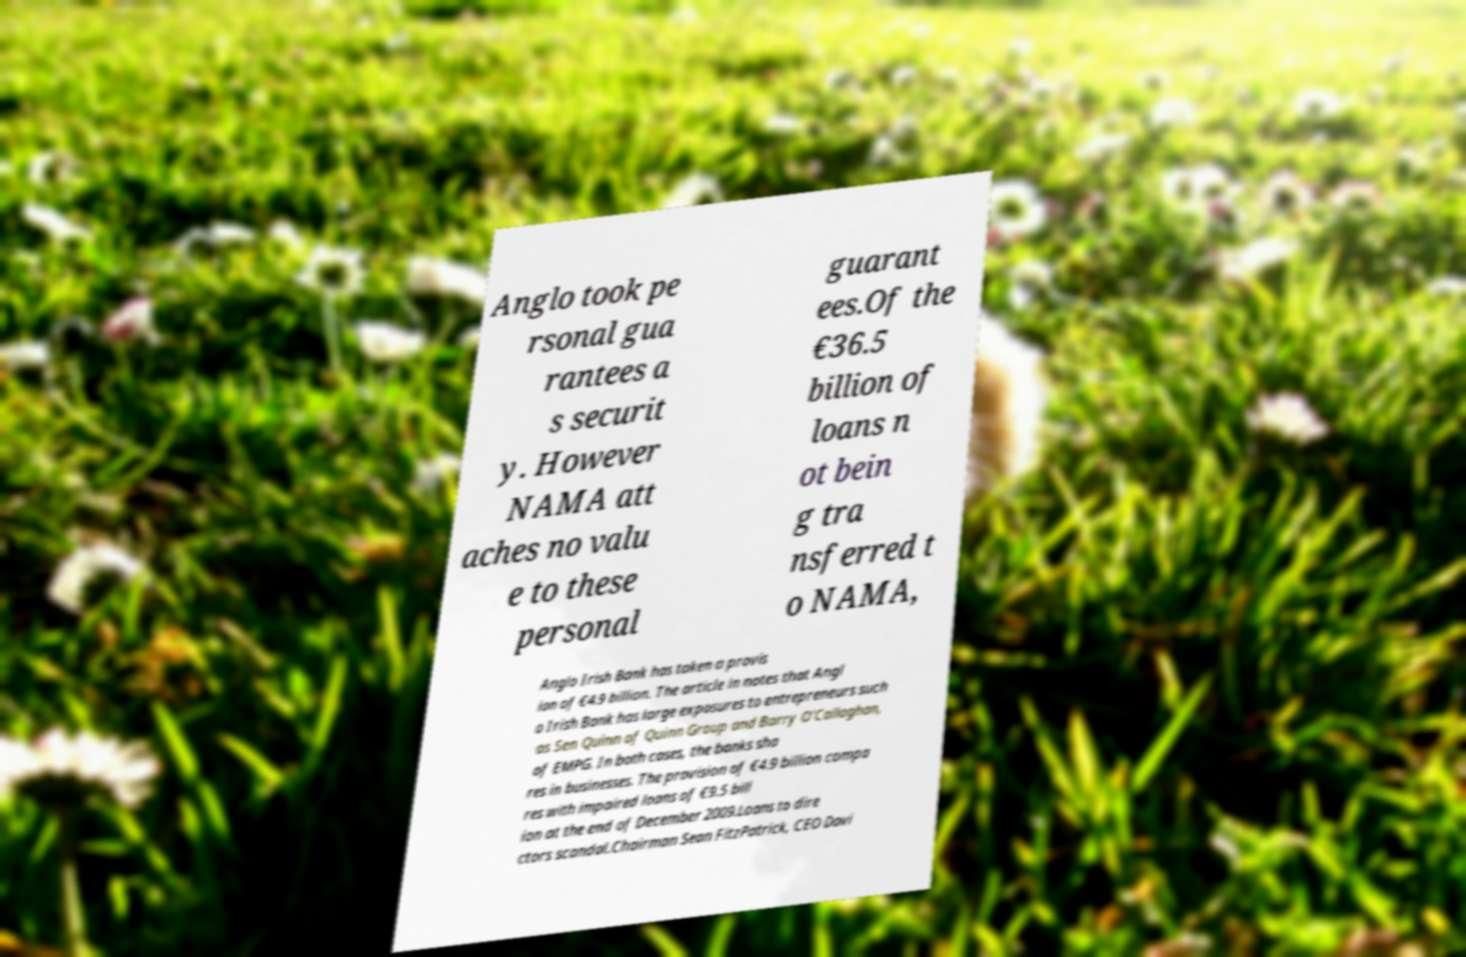Could you assist in decoding the text presented in this image and type it out clearly? Anglo took pe rsonal gua rantees a s securit y. However NAMA att aches no valu e to these personal guarant ees.Of the €36.5 billion of loans n ot bein g tra nsferred t o NAMA, Anglo Irish Bank has taken a provis ion of €4.9 billion. The article in notes that Angl o Irish Bank has large exposures to entrepreneurs such as Sen Quinn of Quinn Group and Barry O’Callaghan, of EMPG. In both cases, the banks sha res in businesses. The provision of €4.9 billion compa res with impaired loans of €9.5 bill ion at the end of December 2009.Loans to dire ctors scandal.Chairman Sean FitzPatrick, CEO Davi 